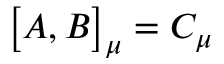Convert formula to latex. <formula><loc_0><loc_0><loc_500><loc_500>\left [ A , B \right ] _ { \mu } = C _ { \mu }</formula> 